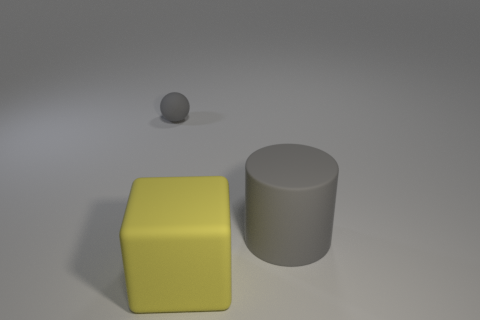What is the material of the gray object in front of the gray object behind the big gray thing?
Provide a short and direct response. Rubber. Are there any matte things of the same color as the large matte cylinder?
Offer a very short reply. Yes. There is a rubber sphere; does it have the same size as the gray thing in front of the matte ball?
Your response must be concise. No. How many small rubber spheres are in front of the large matte object in front of the gray rubber thing in front of the tiny matte object?
Give a very brief answer. 0. How many big matte things are on the right side of the large cube?
Offer a very short reply. 1. There is a object that is in front of the big thing right of the yellow block; what color is it?
Ensure brevity in your answer.  Yellow. Are there the same number of things behind the large yellow thing and gray cylinders?
Your answer should be very brief. No. There is a big object that is in front of the gray object on the right side of the gray thing left of the yellow matte thing; what is it made of?
Give a very brief answer. Rubber. What is the color of the large object that is behind the rubber cube?
Your answer should be very brief. Gray. There is a yellow rubber object that is to the left of the gray rubber thing that is to the right of the large matte cube; what size is it?
Make the answer very short. Large. 